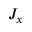<formula> <loc_0><loc_0><loc_500><loc_500>J _ { x }</formula> 